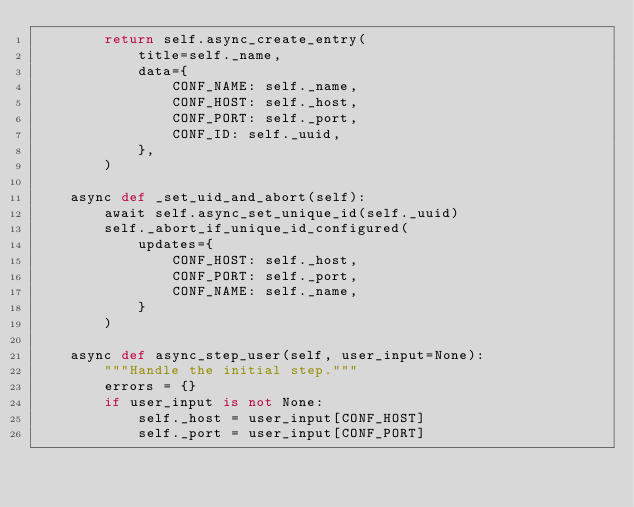Convert code to text. <code><loc_0><loc_0><loc_500><loc_500><_Python_>        return self.async_create_entry(
            title=self._name,
            data={
                CONF_NAME: self._name,
                CONF_HOST: self._host,
                CONF_PORT: self._port,
                CONF_ID: self._uuid,
            },
        )

    async def _set_uid_and_abort(self):
        await self.async_set_unique_id(self._uuid)
        self._abort_if_unique_id_configured(
            updates={
                CONF_HOST: self._host,
                CONF_PORT: self._port,
                CONF_NAME: self._name,
            }
        )

    async def async_step_user(self, user_input=None):
        """Handle the initial step."""
        errors = {}
        if user_input is not None:
            self._host = user_input[CONF_HOST]
            self._port = user_input[CONF_PORT]</code> 